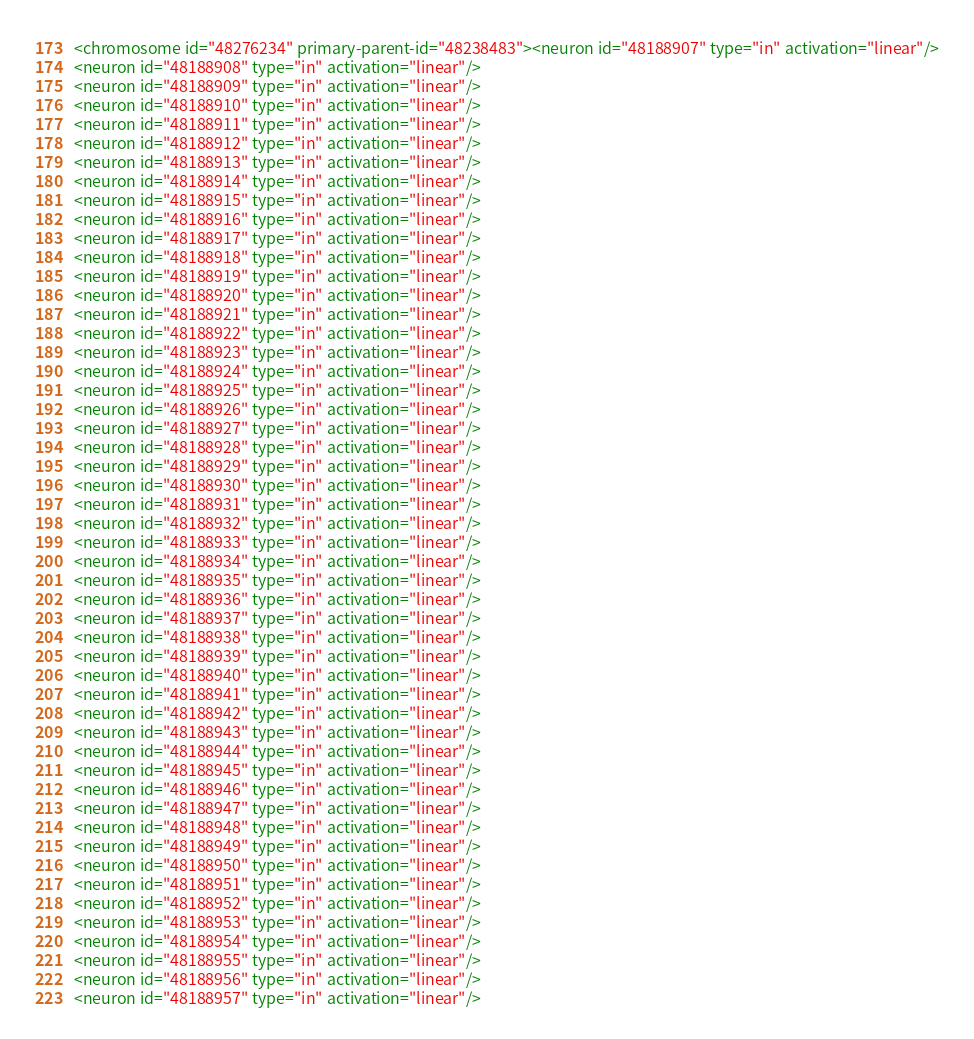Convert code to text. <code><loc_0><loc_0><loc_500><loc_500><_XML_><chromosome id="48276234" primary-parent-id="48238483"><neuron id="48188907" type="in" activation="linear"/>
<neuron id="48188908" type="in" activation="linear"/>
<neuron id="48188909" type="in" activation="linear"/>
<neuron id="48188910" type="in" activation="linear"/>
<neuron id="48188911" type="in" activation="linear"/>
<neuron id="48188912" type="in" activation="linear"/>
<neuron id="48188913" type="in" activation="linear"/>
<neuron id="48188914" type="in" activation="linear"/>
<neuron id="48188915" type="in" activation="linear"/>
<neuron id="48188916" type="in" activation="linear"/>
<neuron id="48188917" type="in" activation="linear"/>
<neuron id="48188918" type="in" activation="linear"/>
<neuron id="48188919" type="in" activation="linear"/>
<neuron id="48188920" type="in" activation="linear"/>
<neuron id="48188921" type="in" activation="linear"/>
<neuron id="48188922" type="in" activation="linear"/>
<neuron id="48188923" type="in" activation="linear"/>
<neuron id="48188924" type="in" activation="linear"/>
<neuron id="48188925" type="in" activation="linear"/>
<neuron id="48188926" type="in" activation="linear"/>
<neuron id="48188927" type="in" activation="linear"/>
<neuron id="48188928" type="in" activation="linear"/>
<neuron id="48188929" type="in" activation="linear"/>
<neuron id="48188930" type="in" activation="linear"/>
<neuron id="48188931" type="in" activation="linear"/>
<neuron id="48188932" type="in" activation="linear"/>
<neuron id="48188933" type="in" activation="linear"/>
<neuron id="48188934" type="in" activation="linear"/>
<neuron id="48188935" type="in" activation="linear"/>
<neuron id="48188936" type="in" activation="linear"/>
<neuron id="48188937" type="in" activation="linear"/>
<neuron id="48188938" type="in" activation="linear"/>
<neuron id="48188939" type="in" activation="linear"/>
<neuron id="48188940" type="in" activation="linear"/>
<neuron id="48188941" type="in" activation="linear"/>
<neuron id="48188942" type="in" activation="linear"/>
<neuron id="48188943" type="in" activation="linear"/>
<neuron id="48188944" type="in" activation="linear"/>
<neuron id="48188945" type="in" activation="linear"/>
<neuron id="48188946" type="in" activation="linear"/>
<neuron id="48188947" type="in" activation="linear"/>
<neuron id="48188948" type="in" activation="linear"/>
<neuron id="48188949" type="in" activation="linear"/>
<neuron id="48188950" type="in" activation="linear"/>
<neuron id="48188951" type="in" activation="linear"/>
<neuron id="48188952" type="in" activation="linear"/>
<neuron id="48188953" type="in" activation="linear"/>
<neuron id="48188954" type="in" activation="linear"/>
<neuron id="48188955" type="in" activation="linear"/>
<neuron id="48188956" type="in" activation="linear"/>
<neuron id="48188957" type="in" activation="linear"/></code> 